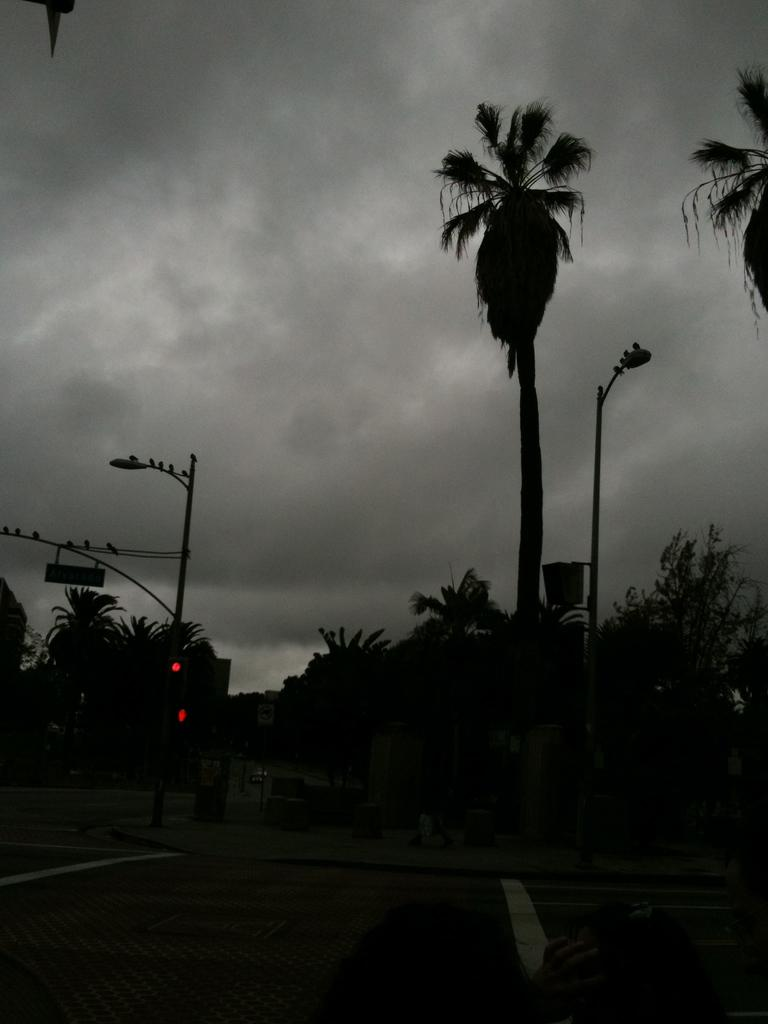What is the main feature of the image? There is a road in the image. What can be seen near the road? There is a traffic signal and poles in the image. What else is present in the image? There are trees and objects in the image. What is visible in the background of the image? The sky is visible in the background of the image. What type of silk is draped over the baseball bat in the image? There is no silk or baseball bat present in the image. 